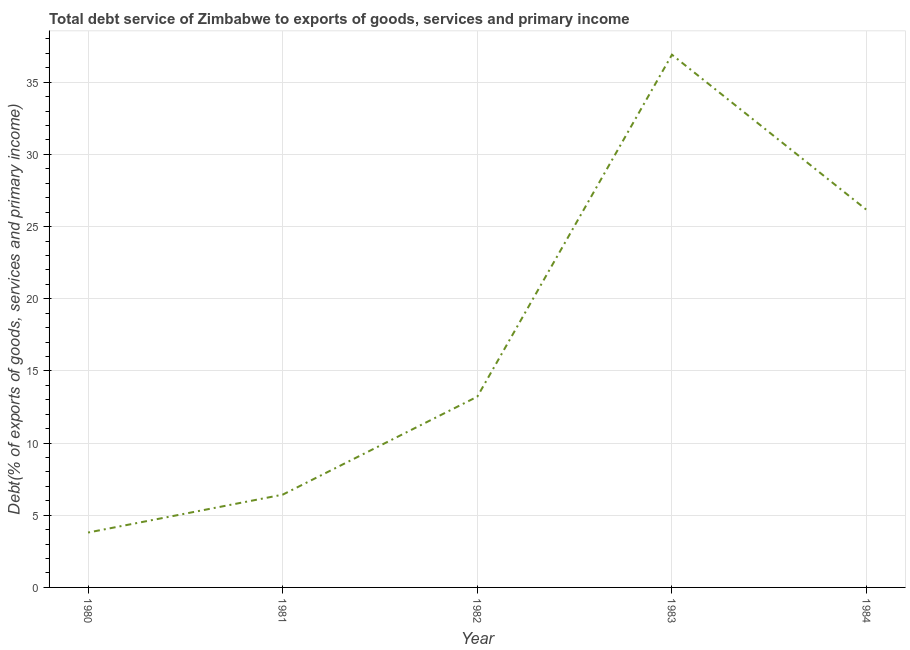What is the total debt service in 1983?
Offer a terse response. 36.91. Across all years, what is the maximum total debt service?
Ensure brevity in your answer.  36.91. Across all years, what is the minimum total debt service?
Your answer should be compact. 3.8. In which year was the total debt service minimum?
Give a very brief answer. 1980. What is the sum of the total debt service?
Your answer should be compact. 86.51. What is the difference between the total debt service in 1980 and 1981?
Your response must be concise. -2.63. What is the average total debt service per year?
Provide a short and direct response. 17.3. What is the median total debt service?
Offer a very short reply. 13.22. What is the ratio of the total debt service in 1982 to that in 1984?
Make the answer very short. 0.51. Is the difference between the total debt service in 1981 and 1982 greater than the difference between any two years?
Offer a very short reply. No. What is the difference between the highest and the second highest total debt service?
Provide a short and direct response. 10.75. What is the difference between the highest and the lowest total debt service?
Provide a succinct answer. 33.11. In how many years, is the total debt service greater than the average total debt service taken over all years?
Keep it short and to the point. 2. Does the total debt service monotonically increase over the years?
Give a very brief answer. No. Does the graph contain grids?
Provide a succinct answer. Yes. What is the title of the graph?
Your answer should be very brief. Total debt service of Zimbabwe to exports of goods, services and primary income. What is the label or title of the X-axis?
Make the answer very short. Year. What is the label or title of the Y-axis?
Your answer should be very brief. Debt(% of exports of goods, services and primary income). What is the Debt(% of exports of goods, services and primary income) in 1980?
Provide a succinct answer. 3.8. What is the Debt(% of exports of goods, services and primary income) in 1981?
Offer a terse response. 6.43. What is the Debt(% of exports of goods, services and primary income) of 1982?
Your answer should be very brief. 13.22. What is the Debt(% of exports of goods, services and primary income) in 1983?
Provide a succinct answer. 36.91. What is the Debt(% of exports of goods, services and primary income) of 1984?
Provide a succinct answer. 26.16. What is the difference between the Debt(% of exports of goods, services and primary income) in 1980 and 1981?
Give a very brief answer. -2.63. What is the difference between the Debt(% of exports of goods, services and primary income) in 1980 and 1982?
Make the answer very short. -9.41. What is the difference between the Debt(% of exports of goods, services and primary income) in 1980 and 1983?
Provide a succinct answer. -33.11. What is the difference between the Debt(% of exports of goods, services and primary income) in 1980 and 1984?
Keep it short and to the point. -22.36. What is the difference between the Debt(% of exports of goods, services and primary income) in 1981 and 1982?
Give a very brief answer. -6.79. What is the difference between the Debt(% of exports of goods, services and primary income) in 1981 and 1983?
Your answer should be compact. -30.48. What is the difference between the Debt(% of exports of goods, services and primary income) in 1981 and 1984?
Your answer should be very brief. -19.73. What is the difference between the Debt(% of exports of goods, services and primary income) in 1982 and 1983?
Your response must be concise. -23.69. What is the difference between the Debt(% of exports of goods, services and primary income) in 1982 and 1984?
Your answer should be compact. -12.94. What is the difference between the Debt(% of exports of goods, services and primary income) in 1983 and 1984?
Your answer should be compact. 10.75. What is the ratio of the Debt(% of exports of goods, services and primary income) in 1980 to that in 1981?
Your response must be concise. 0.59. What is the ratio of the Debt(% of exports of goods, services and primary income) in 1980 to that in 1982?
Your answer should be compact. 0.29. What is the ratio of the Debt(% of exports of goods, services and primary income) in 1980 to that in 1983?
Offer a very short reply. 0.1. What is the ratio of the Debt(% of exports of goods, services and primary income) in 1980 to that in 1984?
Your answer should be compact. 0.14. What is the ratio of the Debt(% of exports of goods, services and primary income) in 1981 to that in 1982?
Give a very brief answer. 0.49. What is the ratio of the Debt(% of exports of goods, services and primary income) in 1981 to that in 1983?
Your response must be concise. 0.17. What is the ratio of the Debt(% of exports of goods, services and primary income) in 1981 to that in 1984?
Your response must be concise. 0.25. What is the ratio of the Debt(% of exports of goods, services and primary income) in 1982 to that in 1983?
Offer a terse response. 0.36. What is the ratio of the Debt(% of exports of goods, services and primary income) in 1982 to that in 1984?
Ensure brevity in your answer.  0.51. What is the ratio of the Debt(% of exports of goods, services and primary income) in 1983 to that in 1984?
Provide a short and direct response. 1.41. 